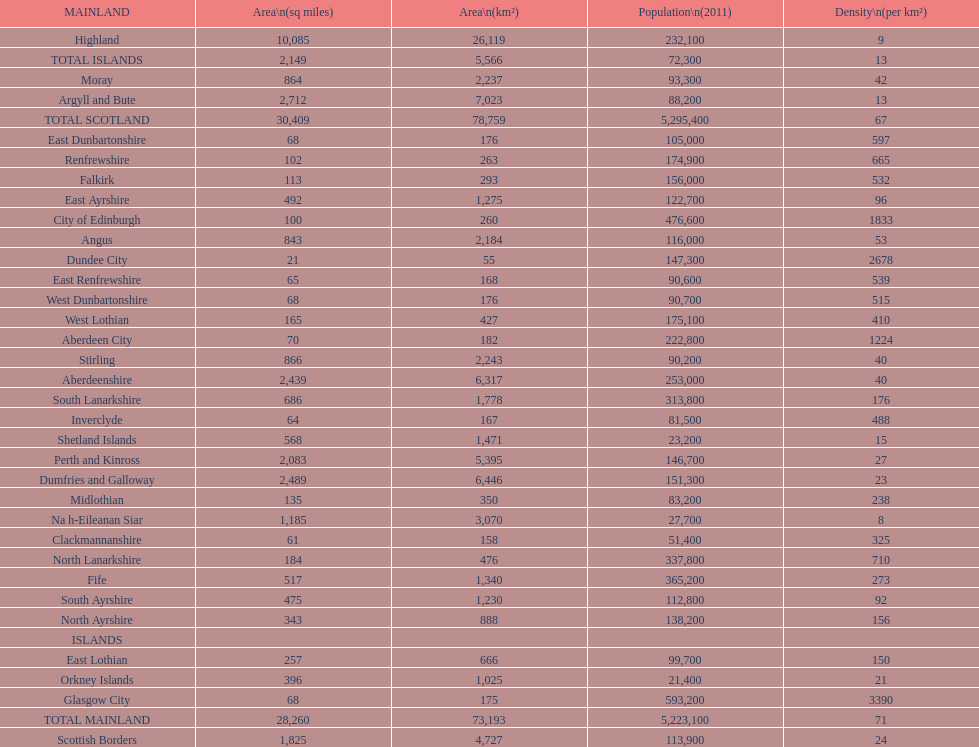Which mainland has the least population? Clackmannanshire. 